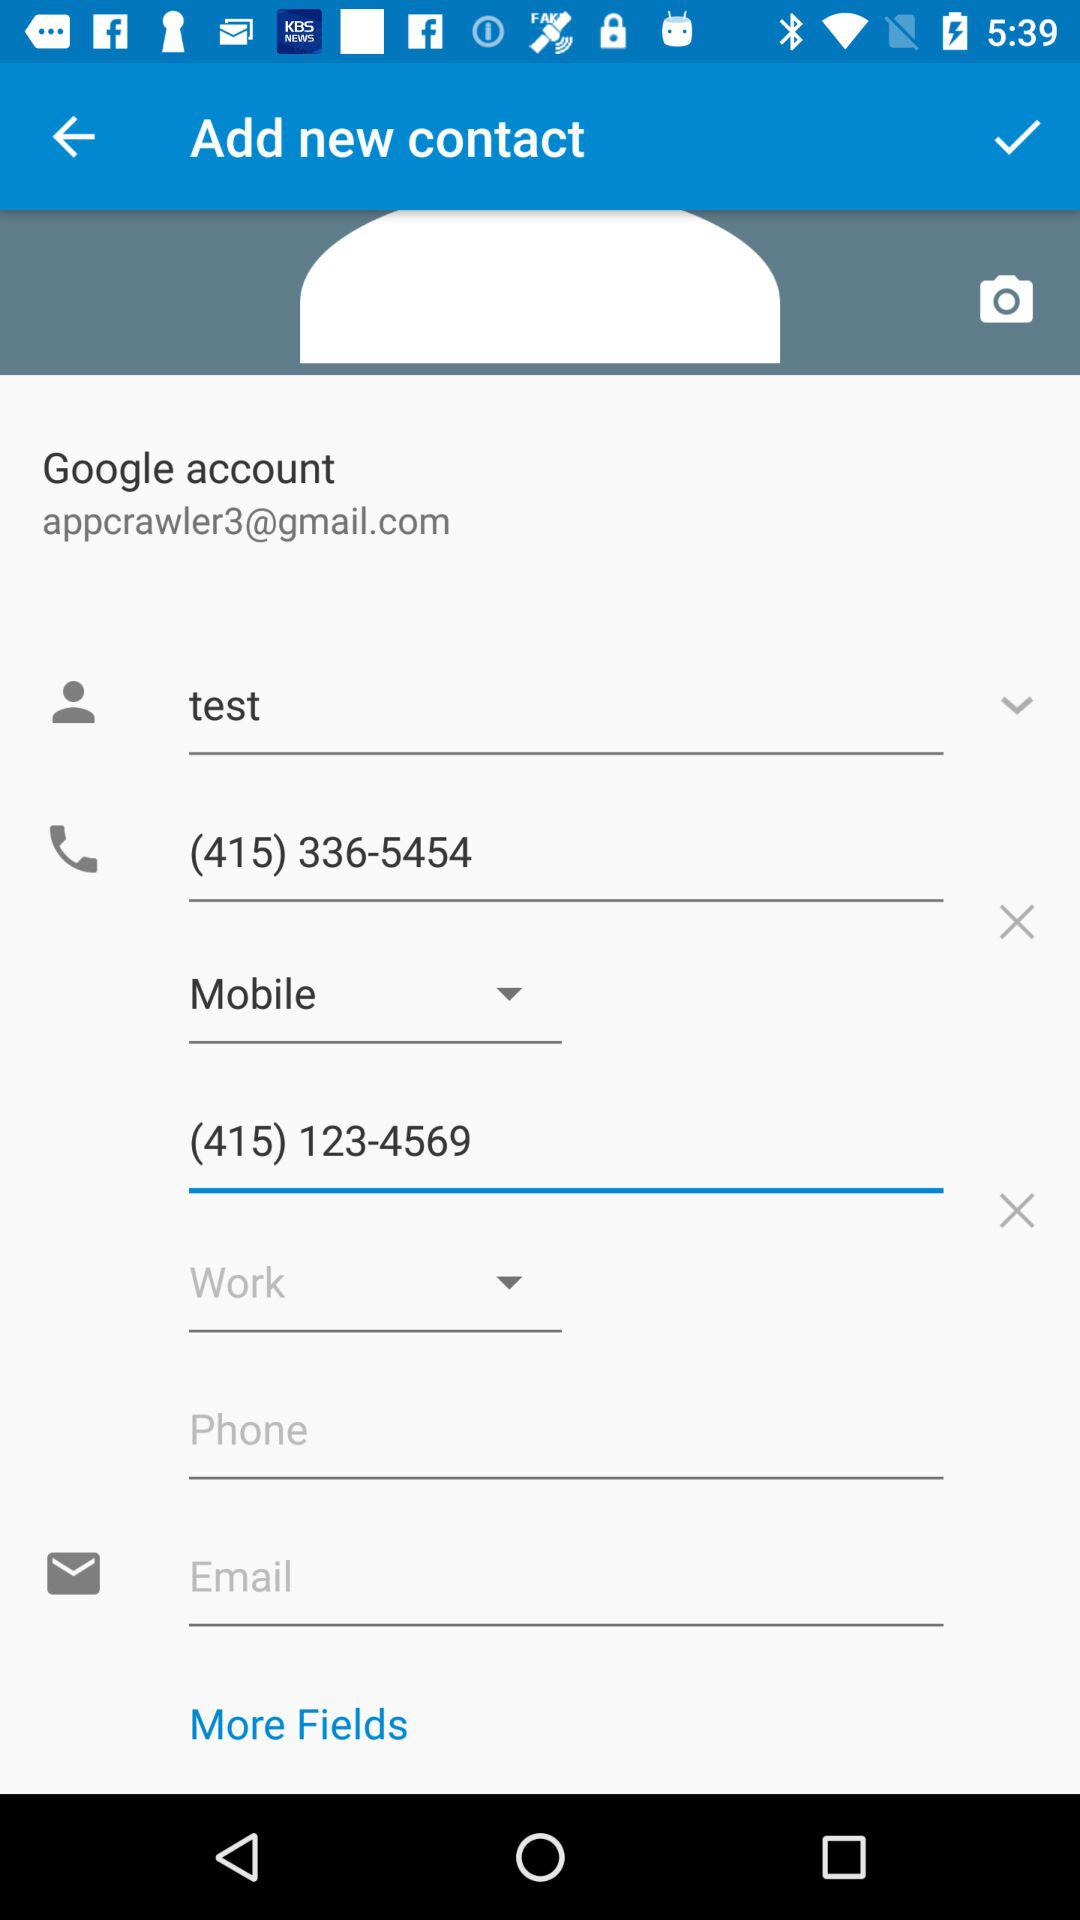What is the email address of the user? The email address of the user is appcrawler3@gmail.com. 